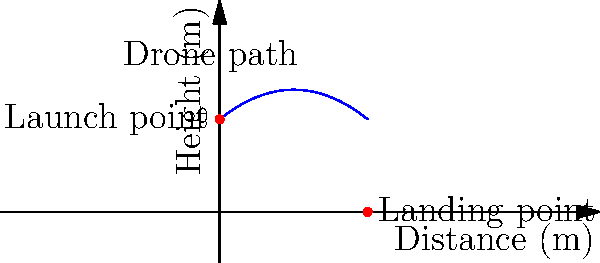As a filmmaker capturing aerial footage in a remote location, you're planning a drone shot that follows a parabolic path. The drone launches from a cliff 10 meters high and lands 16 meters away horizontally. The path of the drone can be modeled by a quadratic function $h(x) = ax^2 + bx + c$, where $x$ is the horizontal distance and $h(x)$ is the height. Given that $h(0) = 10$ and $h(16) = 0$, what is the maximum height reached by the drone during its flight? Let's solve this step-by-step:

1) We know that $h(x) = ax^2 + bx + c$ is our quadratic function.

2) Given $h(0) = 10$, we can conclude that $c = 10$.

3) Now our function is $h(x) = ax^2 + bx + 10$.

4) We also know that $h(16) = 0$. Let's use this:

   $0 = a(16)^2 + b(16) + 10$
   $0 = 256a + 16b + 10$

5) We need one more equation. We can use the fact that the parabola is symmetric. The axis of symmetry is halfway between $x=0$ and $x=16$, so at $x=8$. For a quadratic function, the axis of symmetry is given by $x = -b/(2a)$. So:

   $8 = -b/(2a)$
   $b = -16a$

6) Substituting this into our equation from step 4:

   $0 = 256a + 16(-16a) + 10$
   $0 = 256a - 256a + 10$
   $0 = 10$

   This is always true, so our assumptions are correct.

7) Now, to find the maximum height, we need to find the vertex of the parabola. We know the x-coordinate is 8, so we can plug this into our function:

   $h(8) = a(8)^2 + b(8) + 10$
         $= 64a - 128a + 10$
         $= -64a + 10$

8) To find $a$, we can use the point (16,0):

   $0 = a(16)^2 + b(16) + 10$
   $0 = 256a - 256a + 10$
   $-10 = -256a$
   $a = 10/256 = 5/128 = 0.0390625$

9) Now we can find the maximum height:

   $h(8) = -64(5/128) + 10$
         $= -2.5 + 10$
         $= 7.5$

Therefore, the maximum height reached by the drone is 7.5 meters.
Answer: 7.5 meters 